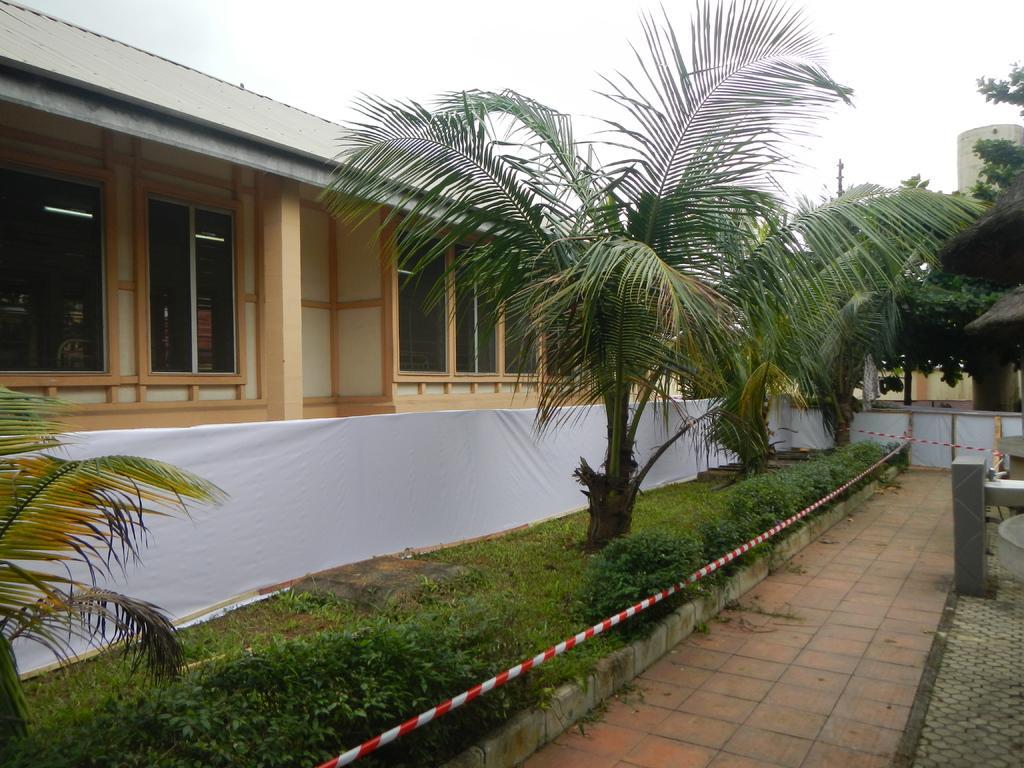How would you summarize this image in a sentence or two? On the right side of the image there are few trees. On the left side of the image there is a building. In the background there is a sky. 